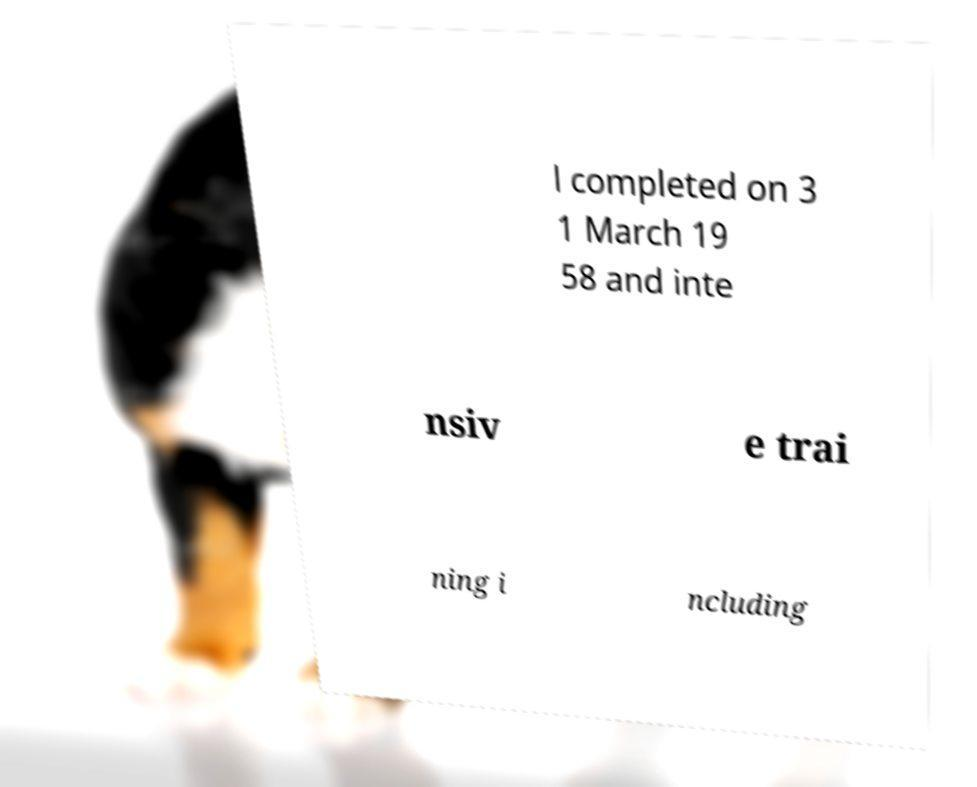Could you assist in decoding the text presented in this image and type it out clearly? l completed on 3 1 March 19 58 and inte nsiv e trai ning i ncluding 